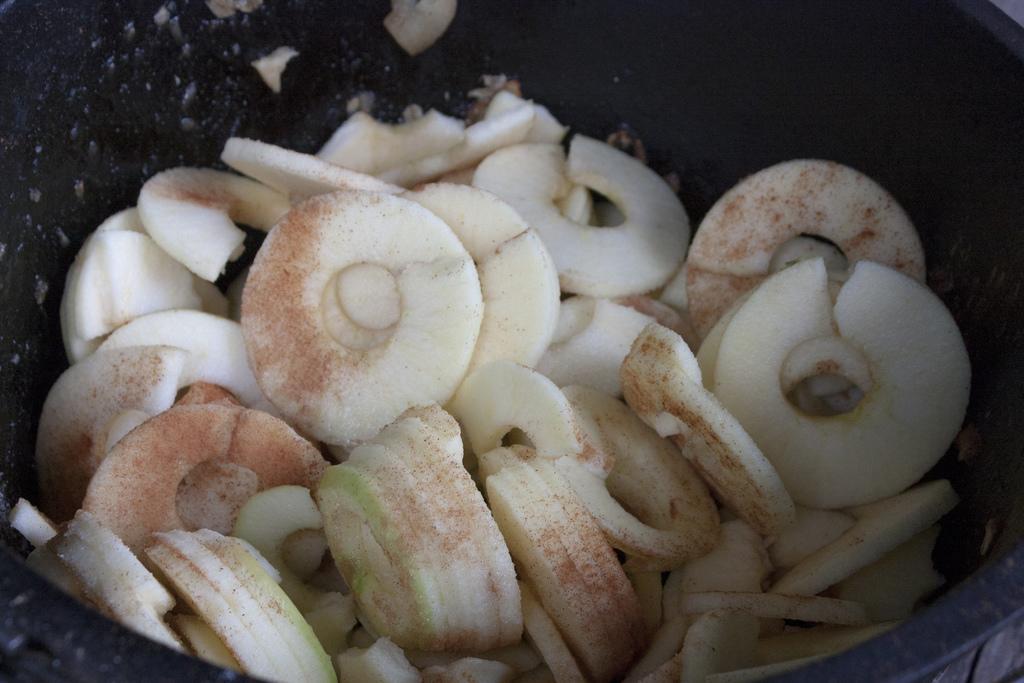Describe this image in one or two sentences. In this picture It looks like some food in the bowl. 